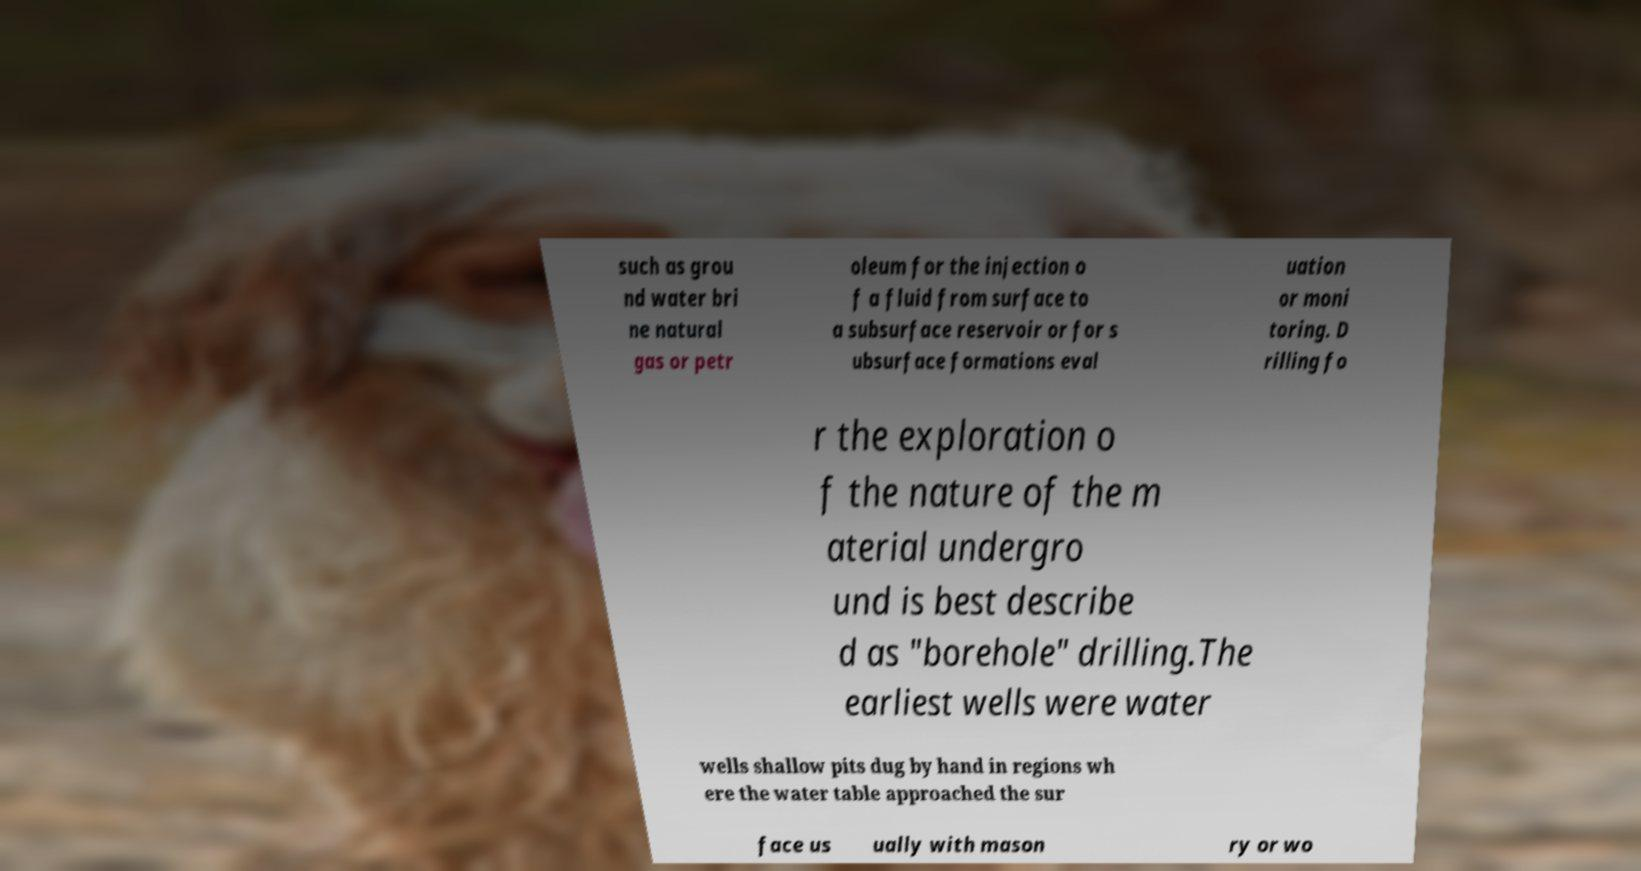I need the written content from this picture converted into text. Can you do that? such as grou nd water bri ne natural gas or petr oleum for the injection o f a fluid from surface to a subsurface reservoir or for s ubsurface formations eval uation or moni toring. D rilling fo r the exploration o f the nature of the m aterial undergro und is best describe d as "borehole" drilling.The earliest wells were water wells shallow pits dug by hand in regions wh ere the water table approached the sur face us ually with mason ry or wo 